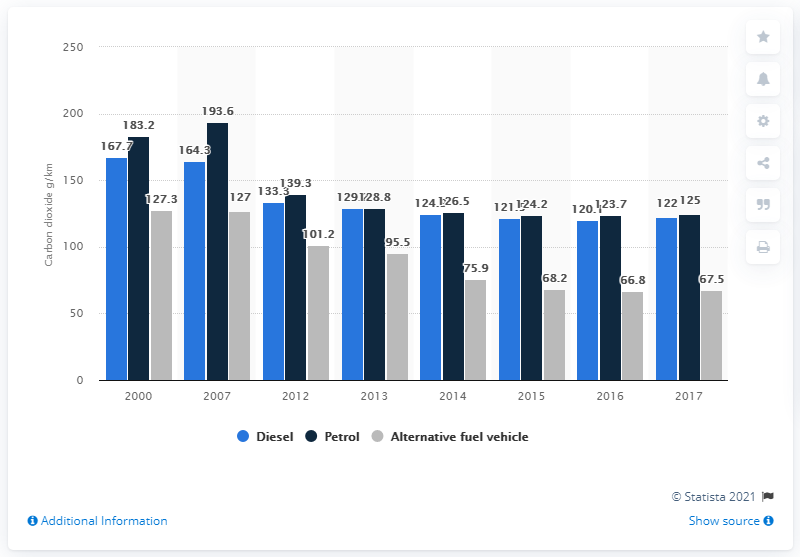List a handful of essential elements in this visual. In 2007, petrol emissions slightly increased. 